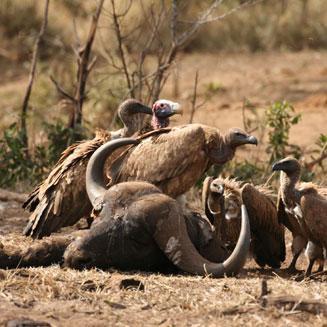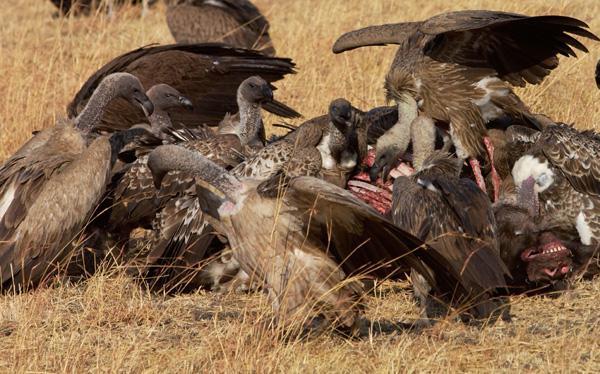The first image is the image on the left, the second image is the image on the right. Evaluate the accuracy of this statement regarding the images: "The vultures in the image on the right are squabbling over bloody remains in an arid, brown landscape with no green grass.". Is it true? Answer yes or no. Yes. The first image is the image on the left, the second image is the image on the right. For the images shown, is this caption "There are more than 5 vulture eating an animal with a set of horns that are visible." true? Answer yes or no. Yes. 